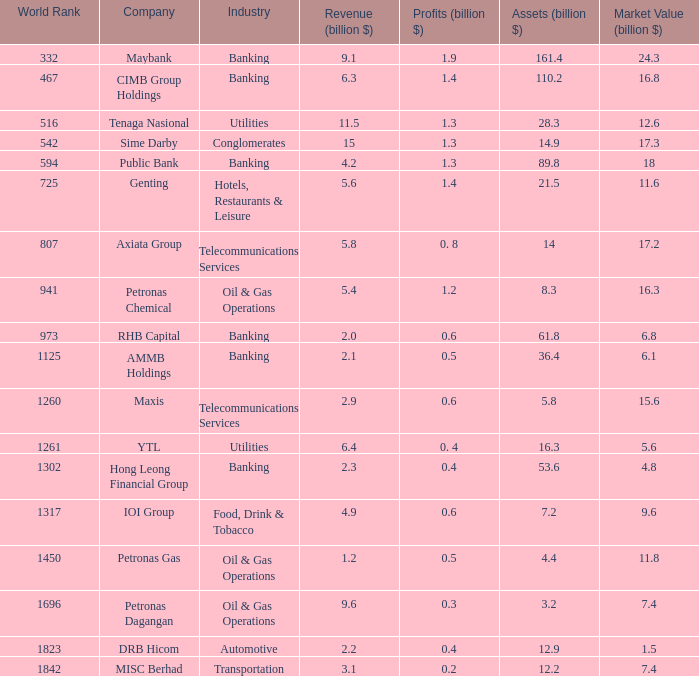Name the total number of industry for maxis 1.0. 